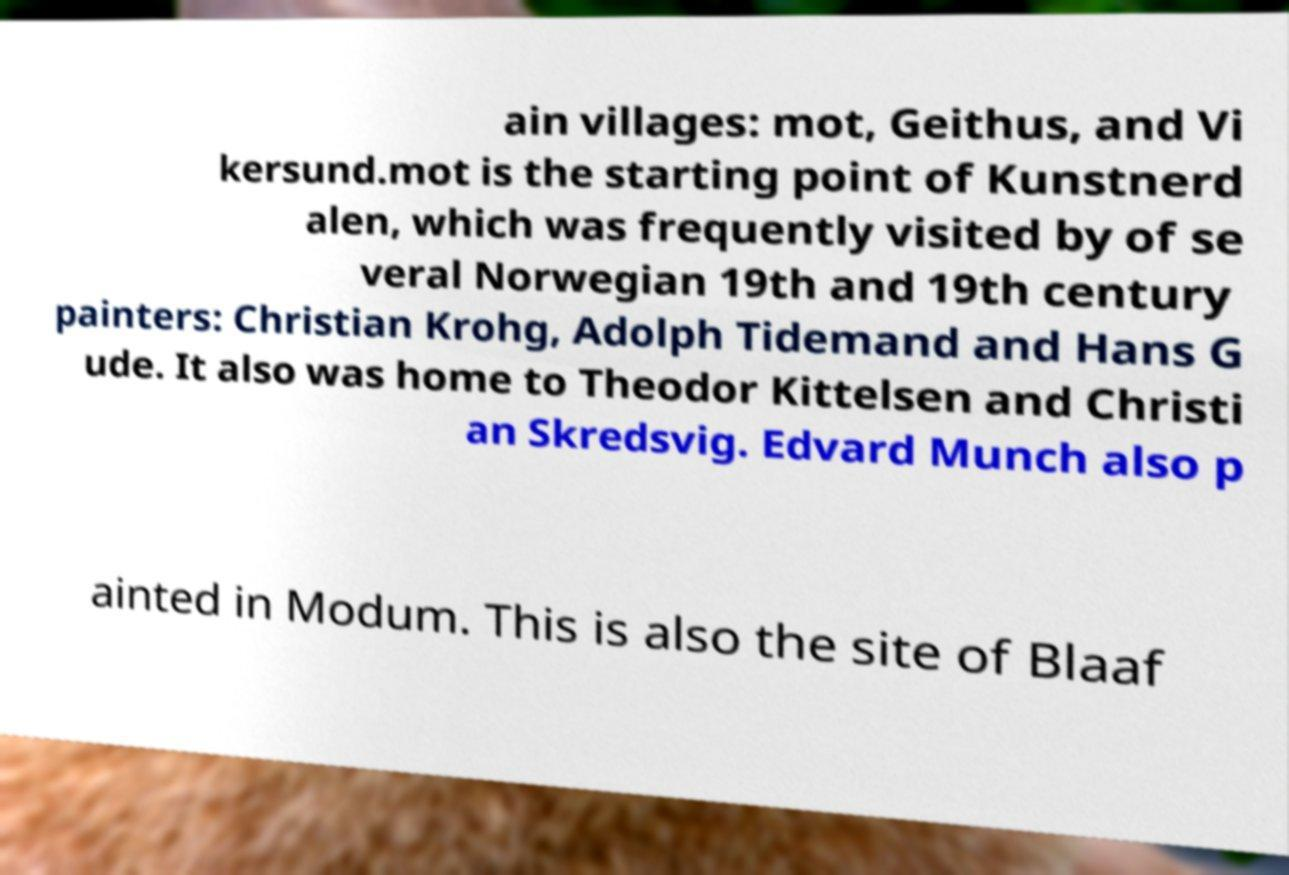Can you accurately transcribe the text from the provided image for me? ain villages: mot, Geithus, and Vi kersund.mot is the starting point of Kunstnerd alen, which was frequently visited by of se veral Norwegian 19th and 19th century painters: Christian Krohg, Adolph Tidemand and Hans G ude. It also was home to Theodor Kittelsen and Christi an Skredsvig. Edvard Munch also p ainted in Modum. This is also the site of Blaaf 